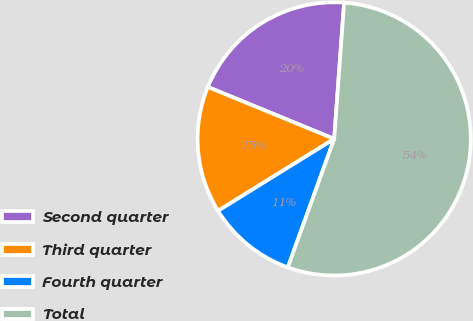Convert chart to OTSL. <chart><loc_0><loc_0><loc_500><loc_500><pie_chart><fcel>Second quarter<fcel>Third quarter<fcel>Fourth quarter<fcel>Total<nl><fcel>19.95%<fcel>15.03%<fcel>10.66%<fcel>54.35%<nl></chart> 